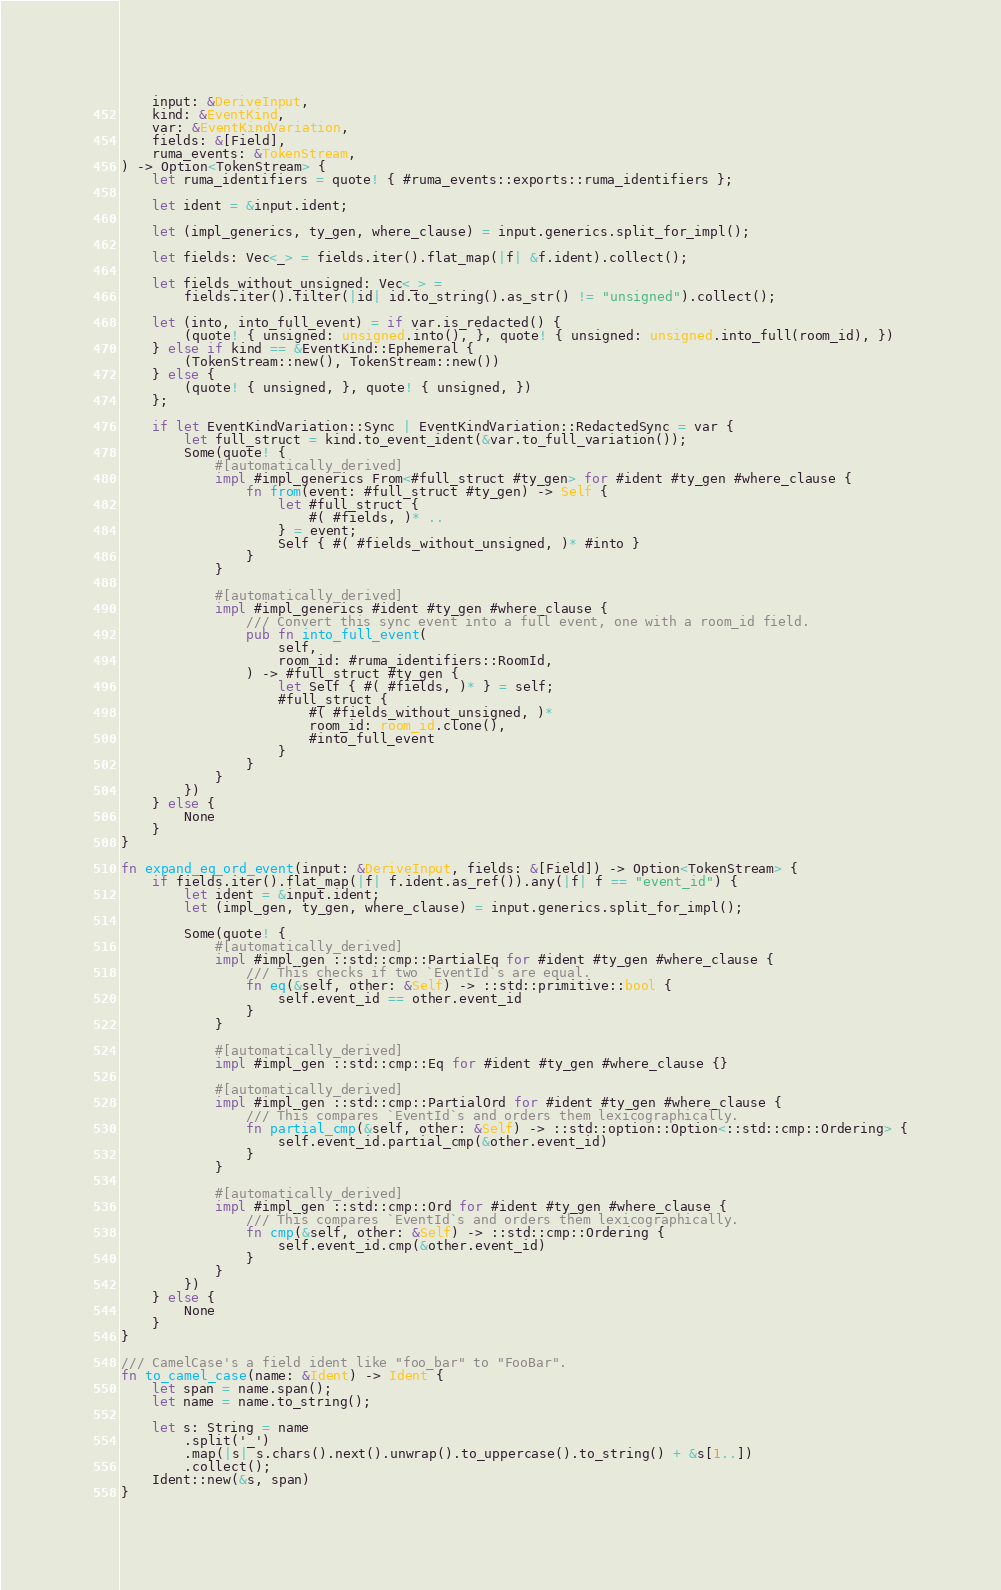Convert code to text. <code><loc_0><loc_0><loc_500><loc_500><_Rust_>    input: &DeriveInput,
    kind: &EventKind,
    var: &EventKindVariation,
    fields: &[Field],
    ruma_events: &TokenStream,
) -> Option<TokenStream> {
    let ruma_identifiers = quote! { #ruma_events::exports::ruma_identifiers };

    let ident = &input.ident;

    let (impl_generics, ty_gen, where_clause) = input.generics.split_for_impl();

    let fields: Vec<_> = fields.iter().flat_map(|f| &f.ident).collect();

    let fields_without_unsigned: Vec<_> =
        fields.iter().filter(|id| id.to_string().as_str() != "unsigned").collect();

    let (into, into_full_event) = if var.is_redacted() {
        (quote! { unsigned: unsigned.into(), }, quote! { unsigned: unsigned.into_full(room_id), })
    } else if kind == &EventKind::Ephemeral {
        (TokenStream::new(), TokenStream::new())
    } else {
        (quote! { unsigned, }, quote! { unsigned, })
    };

    if let EventKindVariation::Sync | EventKindVariation::RedactedSync = var {
        let full_struct = kind.to_event_ident(&var.to_full_variation());
        Some(quote! {
            #[automatically_derived]
            impl #impl_generics From<#full_struct #ty_gen> for #ident #ty_gen #where_clause {
                fn from(event: #full_struct #ty_gen) -> Self {
                    let #full_struct {
                        #( #fields, )* ..
                    } = event;
                    Self { #( #fields_without_unsigned, )* #into }
                }
            }

            #[automatically_derived]
            impl #impl_generics #ident #ty_gen #where_clause {
                /// Convert this sync event into a full event, one with a room_id field.
                pub fn into_full_event(
                    self,
                    room_id: #ruma_identifiers::RoomId,
                ) -> #full_struct #ty_gen {
                    let Self { #( #fields, )* } = self;
                    #full_struct {
                        #( #fields_without_unsigned, )*
                        room_id: room_id.clone(),
                        #into_full_event
                    }
                }
            }
        })
    } else {
        None
    }
}

fn expand_eq_ord_event(input: &DeriveInput, fields: &[Field]) -> Option<TokenStream> {
    if fields.iter().flat_map(|f| f.ident.as_ref()).any(|f| f == "event_id") {
        let ident = &input.ident;
        let (impl_gen, ty_gen, where_clause) = input.generics.split_for_impl();

        Some(quote! {
            #[automatically_derived]
            impl #impl_gen ::std::cmp::PartialEq for #ident #ty_gen #where_clause {
                /// This checks if two `EventId`s are equal.
                fn eq(&self, other: &Self) -> ::std::primitive::bool {
                    self.event_id == other.event_id
                }
            }

            #[automatically_derived]
            impl #impl_gen ::std::cmp::Eq for #ident #ty_gen #where_clause {}

            #[automatically_derived]
            impl #impl_gen ::std::cmp::PartialOrd for #ident #ty_gen #where_clause {
                /// This compares `EventId`s and orders them lexicographically.
                fn partial_cmp(&self, other: &Self) -> ::std::option::Option<::std::cmp::Ordering> {
                    self.event_id.partial_cmp(&other.event_id)
                }
            }

            #[automatically_derived]
            impl #impl_gen ::std::cmp::Ord for #ident #ty_gen #where_clause {
                /// This compares `EventId`s and orders them lexicographically.
                fn cmp(&self, other: &Self) -> ::std::cmp::Ordering {
                    self.event_id.cmp(&other.event_id)
                }
            }
        })
    } else {
        None
    }
}

/// CamelCase's a field ident like "foo_bar" to "FooBar".
fn to_camel_case(name: &Ident) -> Ident {
    let span = name.span();
    let name = name.to_string();

    let s: String = name
        .split('_')
        .map(|s| s.chars().next().unwrap().to_uppercase().to_string() + &s[1..])
        .collect();
    Ident::new(&s, span)
}
</code> 